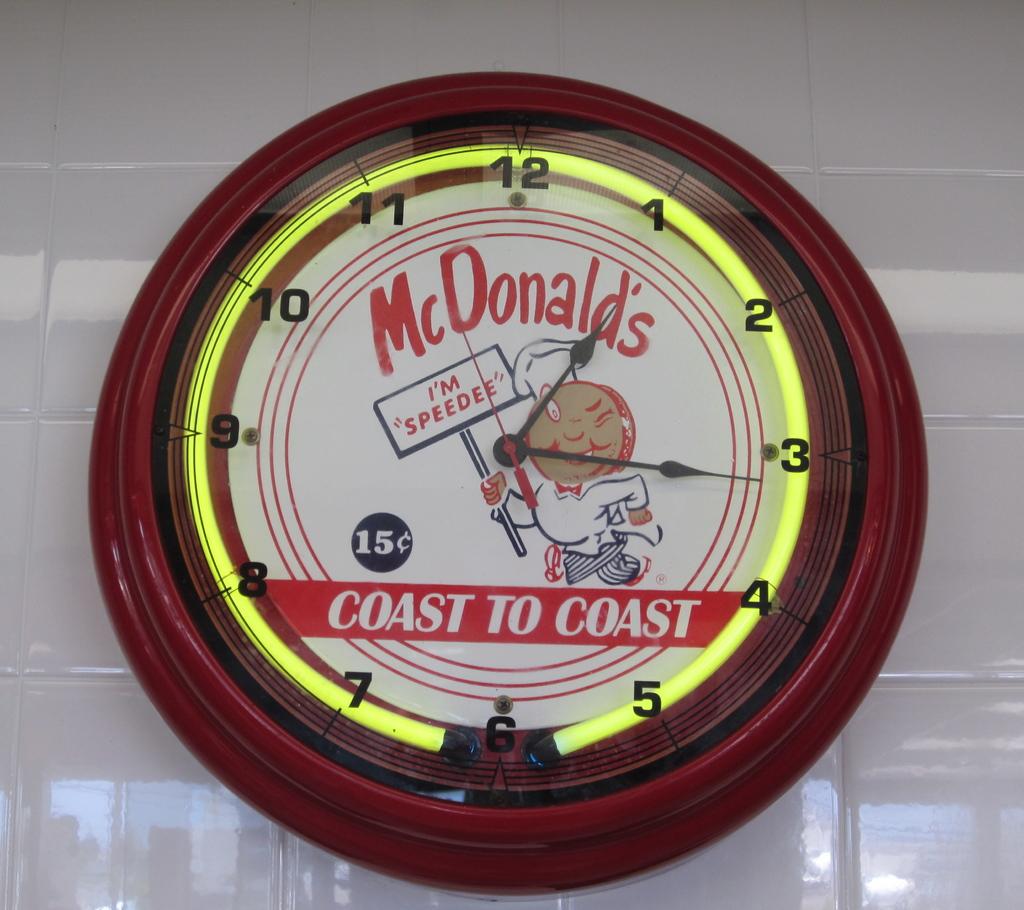What is the slogan for mcdonald's according to the clock?
Make the answer very short. Coast to coast. What time is it?
Your answer should be very brief. 1:16. 